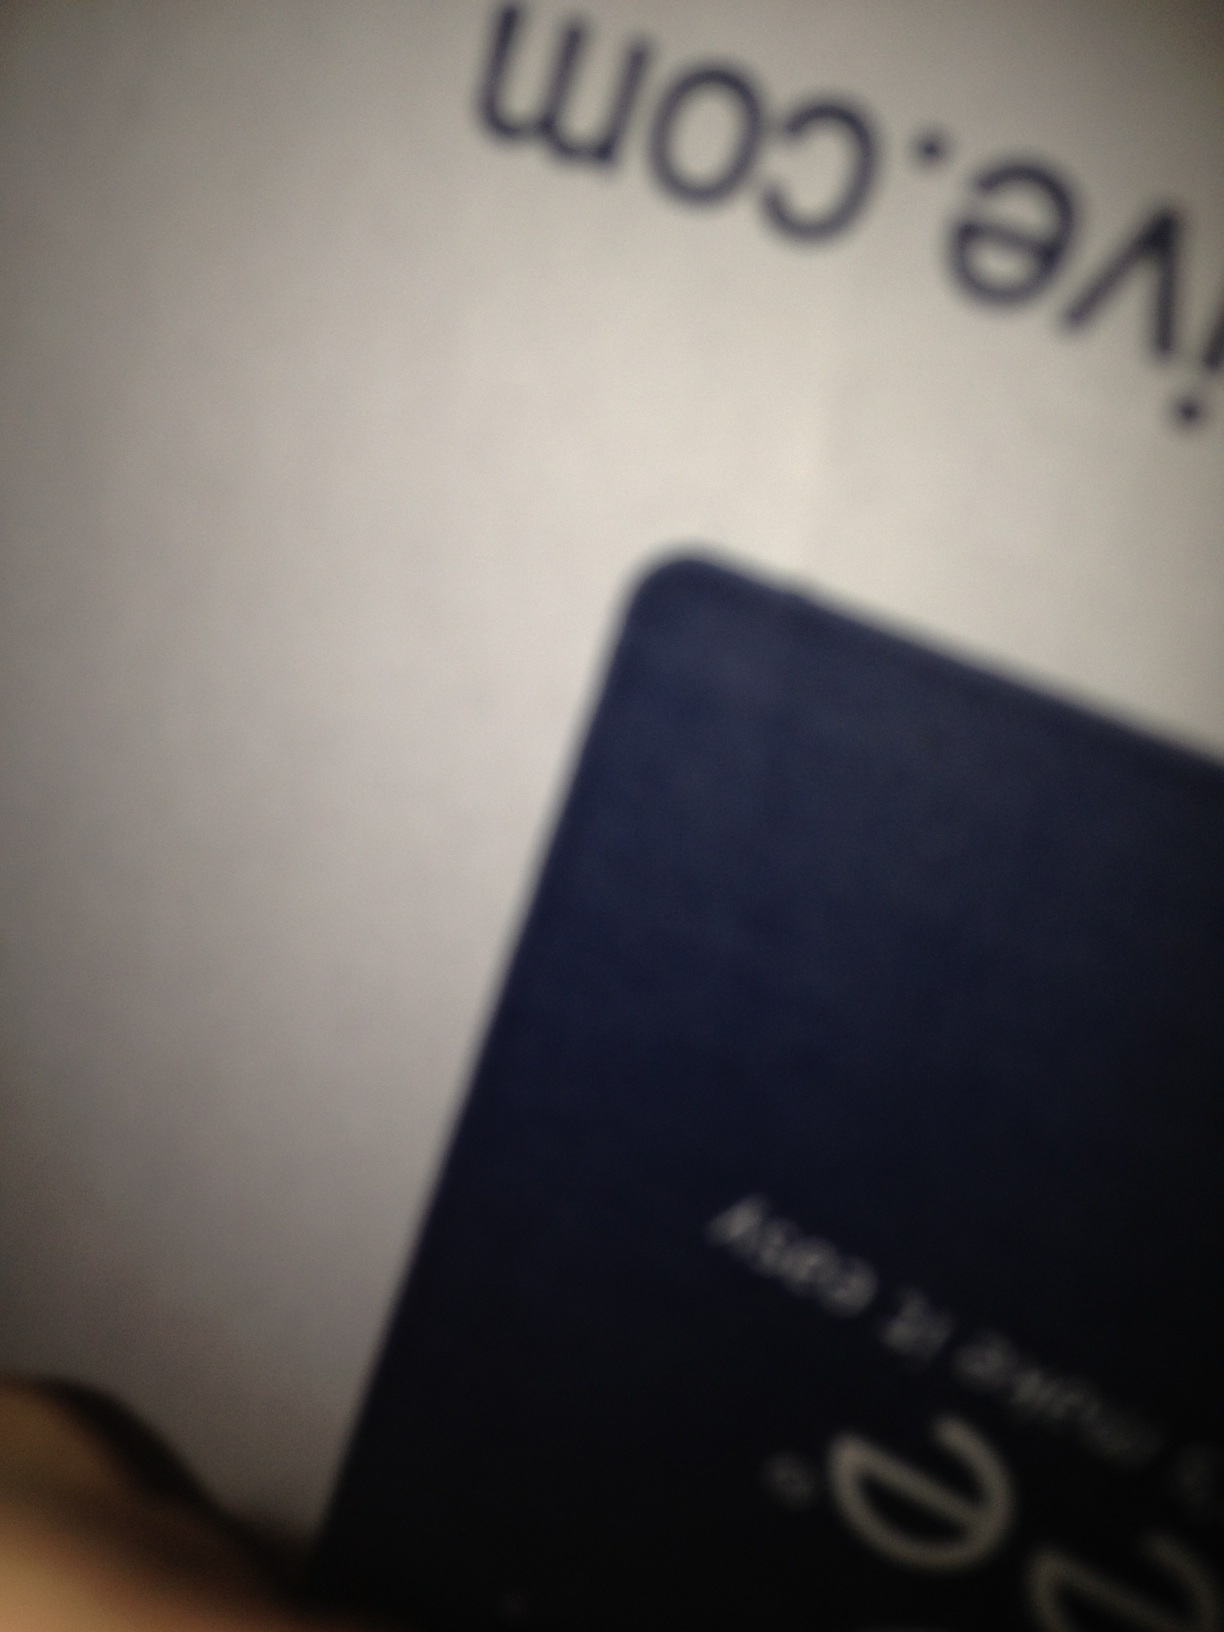Can you describe any text or labels visible on the box despite the blur? The image is blurry, but there seems to be some text near the top of the box. It's not legible enough to read directly from the photo. 